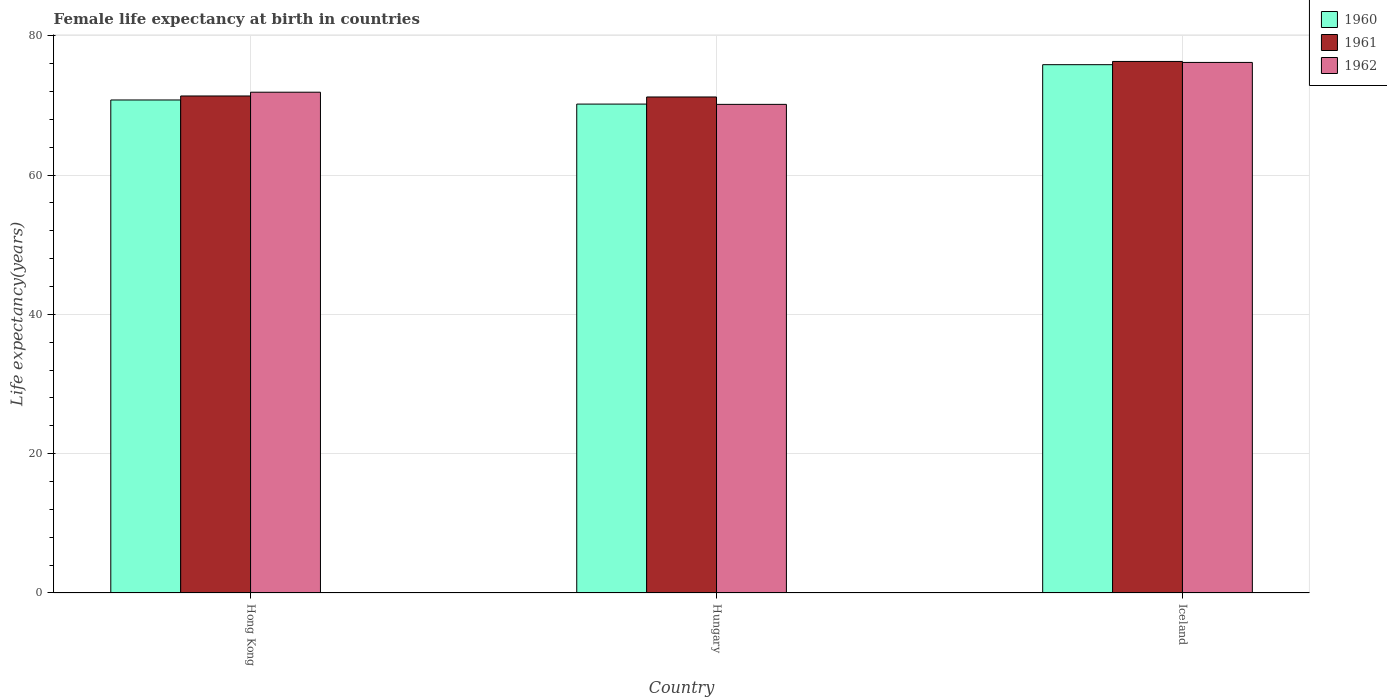How many groups of bars are there?
Keep it short and to the point. 3. Are the number of bars per tick equal to the number of legend labels?
Ensure brevity in your answer.  Yes. How many bars are there on the 1st tick from the left?
Provide a succinct answer. 3. How many bars are there on the 3rd tick from the right?
Provide a short and direct response. 3. What is the label of the 3rd group of bars from the left?
Give a very brief answer. Iceland. In how many cases, is the number of bars for a given country not equal to the number of legend labels?
Keep it short and to the point. 0. What is the female life expectancy at birth in 1960 in Hungary?
Ensure brevity in your answer.  70.18. Across all countries, what is the maximum female life expectancy at birth in 1962?
Provide a short and direct response. 76.16. Across all countries, what is the minimum female life expectancy at birth in 1962?
Make the answer very short. 70.14. In which country was the female life expectancy at birth in 1960 minimum?
Ensure brevity in your answer.  Hungary. What is the total female life expectancy at birth in 1961 in the graph?
Your response must be concise. 218.84. What is the difference between the female life expectancy at birth in 1960 in Hong Kong and that in Hungary?
Give a very brief answer. 0.59. What is the difference between the female life expectancy at birth in 1960 in Iceland and the female life expectancy at birth in 1962 in Hong Kong?
Your answer should be compact. 3.95. What is the average female life expectancy at birth in 1962 per country?
Ensure brevity in your answer.  72.73. What is the difference between the female life expectancy at birth of/in 1962 and female life expectancy at birth of/in 1960 in Hungary?
Offer a very short reply. -0.04. In how many countries, is the female life expectancy at birth in 1961 greater than 44 years?
Give a very brief answer. 3. What is the ratio of the female life expectancy at birth in 1962 in Hong Kong to that in Iceland?
Ensure brevity in your answer.  0.94. Is the difference between the female life expectancy at birth in 1962 in Hungary and Iceland greater than the difference between the female life expectancy at birth in 1960 in Hungary and Iceland?
Offer a terse response. No. What is the difference between the highest and the second highest female life expectancy at birth in 1961?
Give a very brief answer. 5.1. What is the difference between the highest and the lowest female life expectancy at birth in 1961?
Make the answer very short. 5.1. Is the sum of the female life expectancy at birth in 1960 in Hong Kong and Iceland greater than the maximum female life expectancy at birth in 1961 across all countries?
Give a very brief answer. Yes. What does the 2nd bar from the left in Hungary represents?
Ensure brevity in your answer.  1961. How many bars are there?
Your response must be concise. 9. How many countries are there in the graph?
Your answer should be very brief. 3. Are the values on the major ticks of Y-axis written in scientific E-notation?
Give a very brief answer. No. Does the graph contain any zero values?
Offer a terse response. No. What is the title of the graph?
Offer a very short reply. Female life expectancy at birth in countries. What is the label or title of the Y-axis?
Your answer should be compact. Life expectancy(years). What is the Life expectancy(years) of 1960 in Hong Kong?
Make the answer very short. 70.77. What is the Life expectancy(years) in 1961 in Hong Kong?
Offer a very short reply. 71.34. What is the Life expectancy(years) in 1962 in Hong Kong?
Your answer should be compact. 71.89. What is the Life expectancy(years) of 1960 in Hungary?
Your answer should be very brief. 70.18. What is the Life expectancy(years) in 1961 in Hungary?
Your answer should be very brief. 71.2. What is the Life expectancy(years) in 1962 in Hungary?
Give a very brief answer. 70.14. What is the Life expectancy(years) of 1960 in Iceland?
Offer a terse response. 75.84. What is the Life expectancy(years) of 1961 in Iceland?
Ensure brevity in your answer.  76.3. What is the Life expectancy(years) of 1962 in Iceland?
Ensure brevity in your answer.  76.16. Across all countries, what is the maximum Life expectancy(years) in 1960?
Offer a very short reply. 75.84. Across all countries, what is the maximum Life expectancy(years) in 1961?
Your answer should be compact. 76.3. Across all countries, what is the maximum Life expectancy(years) in 1962?
Offer a very short reply. 76.16. Across all countries, what is the minimum Life expectancy(years) of 1960?
Keep it short and to the point. 70.18. Across all countries, what is the minimum Life expectancy(years) of 1961?
Provide a short and direct response. 71.2. Across all countries, what is the minimum Life expectancy(years) of 1962?
Ensure brevity in your answer.  70.14. What is the total Life expectancy(years) of 1960 in the graph?
Provide a succinct answer. 216.79. What is the total Life expectancy(years) in 1961 in the graph?
Keep it short and to the point. 218.84. What is the total Life expectancy(years) of 1962 in the graph?
Make the answer very short. 218.19. What is the difference between the Life expectancy(years) in 1960 in Hong Kong and that in Hungary?
Keep it short and to the point. 0.59. What is the difference between the Life expectancy(years) of 1961 in Hong Kong and that in Hungary?
Your answer should be very brief. 0.14. What is the difference between the Life expectancy(years) of 1962 in Hong Kong and that in Hungary?
Ensure brevity in your answer.  1.75. What is the difference between the Life expectancy(years) in 1960 in Hong Kong and that in Iceland?
Your response must be concise. -5.07. What is the difference between the Life expectancy(years) in 1961 in Hong Kong and that in Iceland?
Your answer should be compact. -4.96. What is the difference between the Life expectancy(years) in 1962 in Hong Kong and that in Iceland?
Keep it short and to the point. -4.28. What is the difference between the Life expectancy(years) of 1960 in Hungary and that in Iceland?
Your answer should be very brief. -5.66. What is the difference between the Life expectancy(years) of 1961 in Hungary and that in Iceland?
Ensure brevity in your answer.  -5.1. What is the difference between the Life expectancy(years) of 1962 in Hungary and that in Iceland?
Provide a short and direct response. -6.02. What is the difference between the Life expectancy(years) in 1960 in Hong Kong and the Life expectancy(years) in 1961 in Hungary?
Provide a succinct answer. -0.43. What is the difference between the Life expectancy(years) in 1960 in Hong Kong and the Life expectancy(years) in 1962 in Hungary?
Offer a terse response. 0.63. What is the difference between the Life expectancy(years) in 1961 in Hong Kong and the Life expectancy(years) in 1962 in Hungary?
Offer a terse response. 1.2. What is the difference between the Life expectancy(years) in 1960 in Hong Kong and the Life expectancy(years) in 1961 in Iceland?
Your response must be concise. -5.53. What is the difference between the Life expectancy(years) in 1960 in Hong Kong and the Life expectancy(years) in 1962 in Iceland?
Ensure brevity in your answer.  -5.39. What is the difference between the Life expectancy(years) of 1961 in Hong Kong and the Life expectancy(years) of 1962 in Iceland?
Provide a short and direct response. -4.82. What is the difference between the Life expectancy(years) in 1960 in Hungary and the Life expectancy(years) in 1961 in Iceland?
Ensure brevity in your answer.  -6.12. What is the difference between the Life expectancy(years) in 1960 in Hungary and the Life expectancy(years) in 1962 in Iceland?
Offer a terse response. -5.98. What is the difference between the Life expectancy(years) of 1961 in Hungary and the Life expectancy(years) of 1962 in Iceland?
Your answer should be compact. -4.96. What is the average Life expectancy(years) of 1960 per country?
Your response must be concise. 72.26. What is the average Life expectancy(years) of 1961 per country?
Your response must be concise. 72.95. What is the average Life expectancy(years) in 1962 per country?
Make the answer very short. 72.73. What is the difference between the Life expectancy(years) of 1960 and Life expectancy(years) of 1961 in Hong Kong?
Give a very brief answer. -0.57. What is the difference between the Life expectancy(years) in 1960 and Life expectancy(years) in 1962 in Hong Kong?
Your answer should be very brief. -1.11. What is the difference between the Life expectancy(years) of 1961 and Life expectancy(years) of 1962 in Hong Kong?
Keep it short and to the point. -0.54. What is the difference between the Life expectancy(years) in 1960 and Life expectancy(years) in 1961 in Hungary?
Provide a short and direct response. -1.02. What is the difference between the Life expectancy(years) of 1961 and Life expectancy(years) of 1962 in Hungary?
Provide a succinct answer. 1.06. What is the difference between the Life expectancy(years) of 1960 and Life expectancy(years) of 1961 in Iceland?
Make the answer very short. -0.46. What is the difference between the Life expectancy(years) in 1960 and Life expectancy(years) in 1962 in Iceland?
Offer a very short reply. -0.32. What is the difference between the Life expectancy(years) of 1961 and Life expectancy(years) of 1962 in Iceland?
Your answer should be compact. 0.14. What is the ratio of the Life expectancy(years) in 1960 in Hong Kong to that in Hungary?
Keep it short and to the point. 1.01. What is the ratio of the Life expectancy(years) in 1962 in Hong Kong to that in Hungary?
Provide a succinct answer. 1.02. What is the ratio of the Life expectancy(years) in 1960 in Hong Kong to that in Iceland?
Make the answer very short. 0.93. What is the ratio of the Life expectancy(years) of 1961 in Hong Kong to that in Iceland?
Your answer should be very brief. 0.94. What is the ratio of the Life expectancy(years) in 1962 in Hong Kong to that in Iceland?
Give a very brief answer. 0.94. What is the ratio of the Life expectancy(years) of 1960 in Hungary to that in Iceland?
Ensure brevity in your answer.  0.93. What is the ratio of the Life expectancy(years) of 1961 in Hungary to that in Iceland?
Make the answer very short. 0.93. What is the ratio of the Life expectancy(years) in 1962 in Hungary to that in Iceland?
Give a very brief answer. 0.92. What is the difference between the highest and the second highest Life expectancy(years) in 1960?
Make the answer very short. 5.07. What is the difference between the highest and the second highest Life expectancy(years) in 1961?
Your answer should be compact. 4.96. What is the difference between the highest and the second highest Life expectancy(years) of 1962?
Your answer should be very brief. 4.28. What is the difference between the highest and the lowest Life expectancy(years) in 1960?
Offer a very short reply. 5.66. What is the difference between the highest and the lowest Life expectancy(years) in 1962?
Keep it short and to the point. 6.02. 